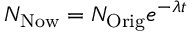Convert formula to latex. <formula><loc_0><loc_0><loc_500><loc_500>N _ { N o w } = N _ { O r i g } e ^ { - \lambda t }</formula> 